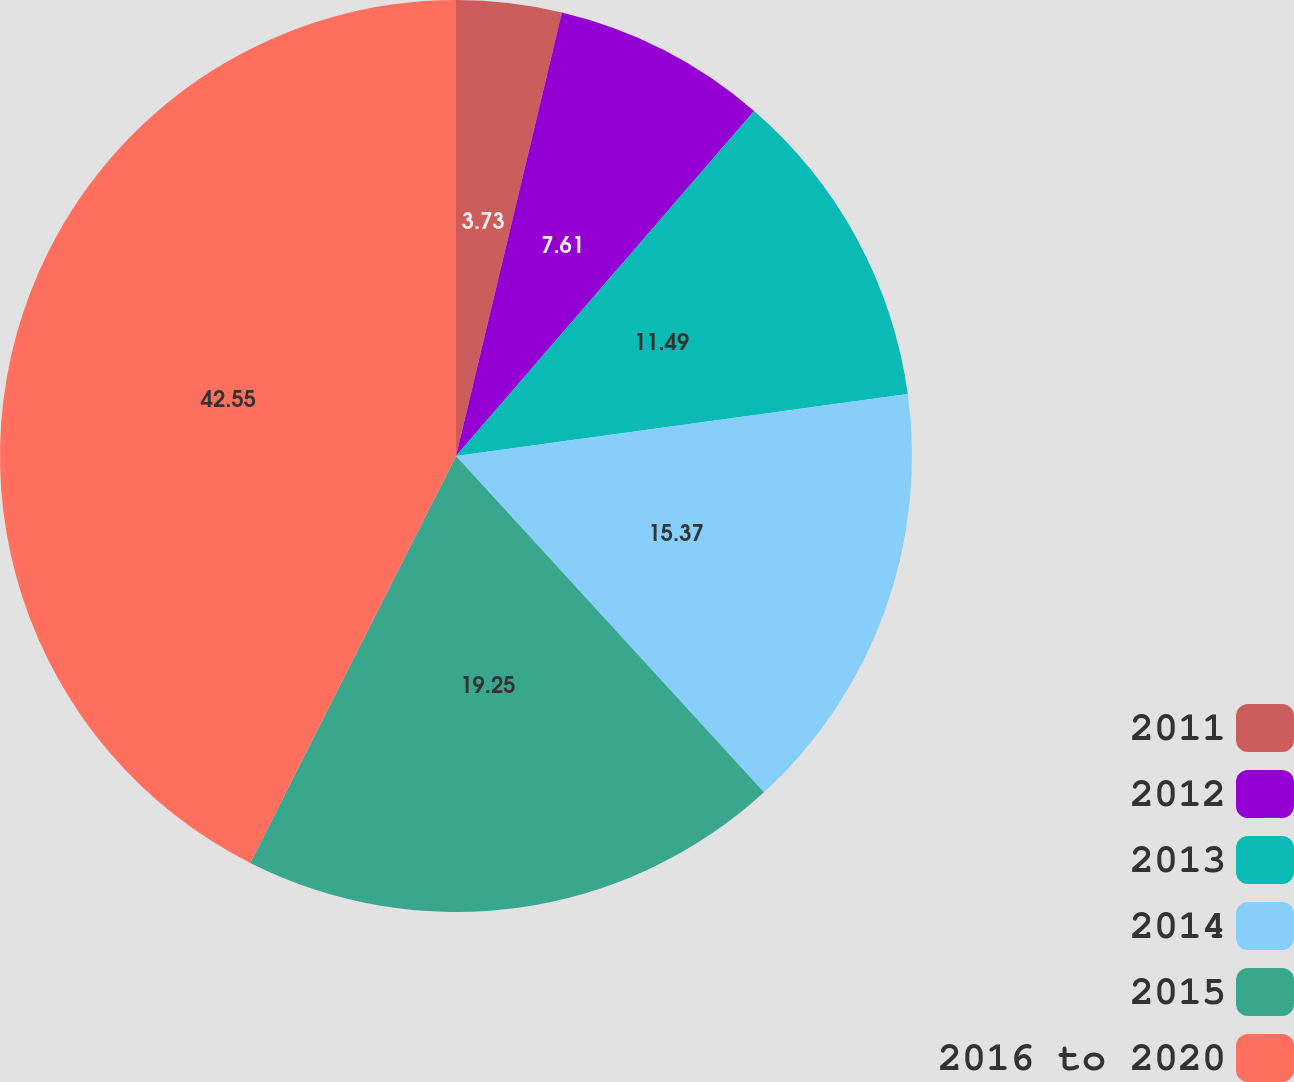<chart> <loc_0><loc_0><loc_500><loc_500><pie_chart><fcel>2011<fcel>2012<fcel>2013<fcel>2014<fcel>2015<fcel>2016 to 2020<nl><fcel>3.73%<fcel>7.61%<fcel>11.49%<fcel>15.37%<fcel>19.25%<fcel>42.55%<nl></chart> 